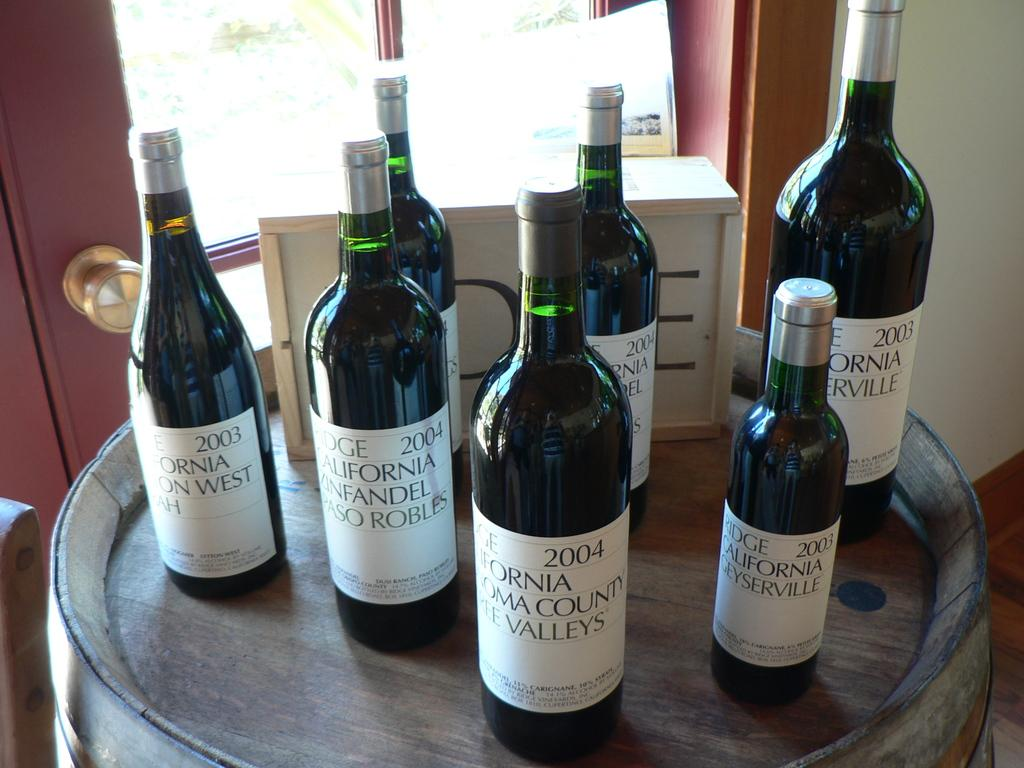<image>
Create a compact narrative representing the image presented. several wine bottles from a california company from the early 2000s 